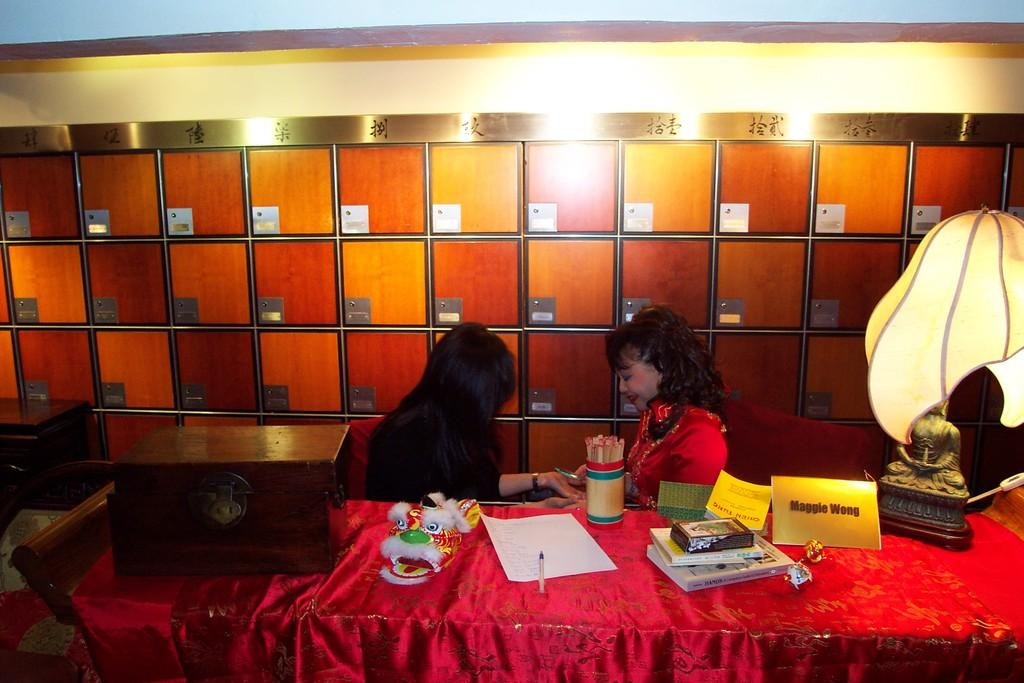How many people are in the image? There are two persons in the image. Can you describe the individuals in the image? One of the persons is a woman, and the other person is a girl. What is present on the table in the image? There is a pen, a paper, books, and other unspecified items on the table. What type of seed can be seen growing on the woman's head in the image? There is no seed or plant growing on the woman's head in the image. 